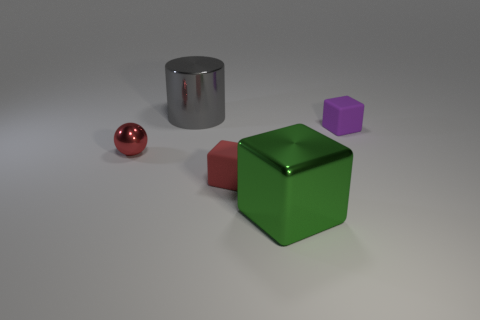Subtract all small red rubber cubes. How many cubes are left? 2 Subtract 1 cylinders. How many cylinders are left? 0 Add 1 shiny blocks. How many objects exist? 6 Subtract all purple blocks. How many blocks are left? 2 Subtract 0 brown cylinders. How many objects are left? 5 Subtract all cylinders. How many objects are left? 4 Subtract all red cubes. Subtract all red cylinders. How many cubes are left? 2 Subtract all green cylinders. How many red cubes are left? 1 Subtract all cyan cylinders. Subtract all shiny blocks. How many objects are left? 4 Add 1 red spheres. How many red spheres are left? 2 